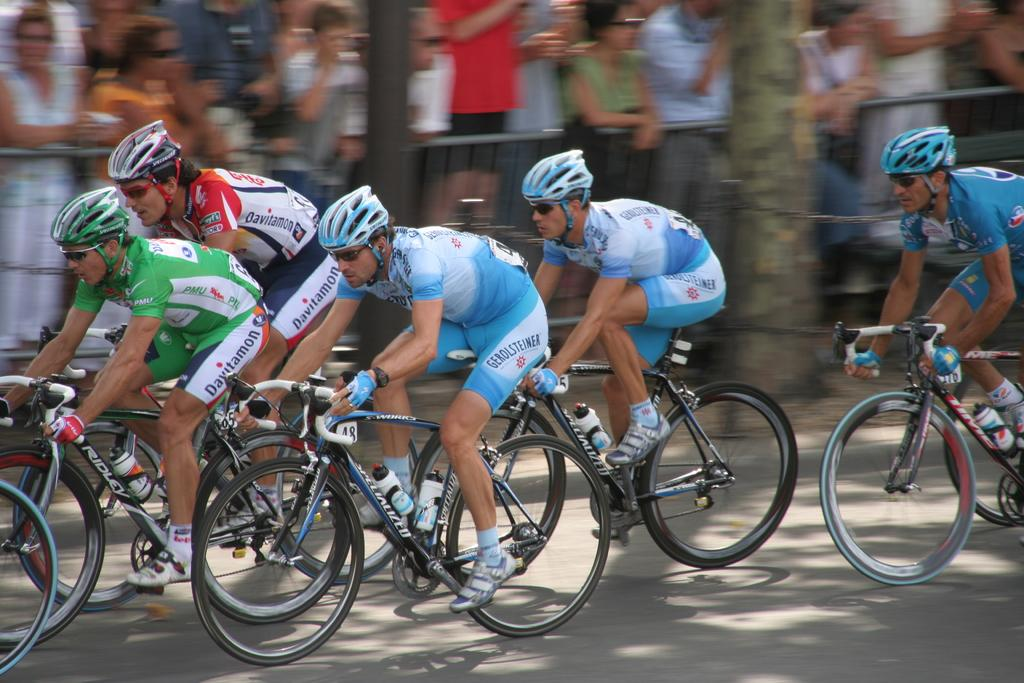What are the men in the image doing? The men in the image are riding bicycles. What safety precaution are the men taking while riding their bicycles? The men are wearing helmets. What can be seen in the foreground of the image? There is a road in the image. What can be seen in the background of the image? In the background, it is blurry, and there are people, a tree trunk, a fence, and a pole visible. What type of trouble can be seen in the image? There is no trouble visible in the image; it shows men riding bicycles safely and various background elements. 